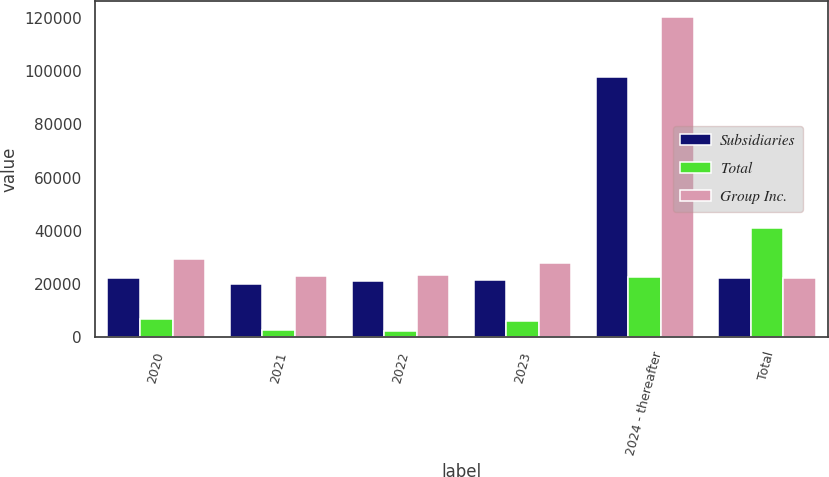<chart> <loc_0><loc_0><loc_500><loc_500><stacked_bar_chart><ecel><fcel>2020<fcel>2021<fcel>2022<fcel>2023<fcel>2024 - thereafter<fcel>Total<nl><fcel>Subsidiaries<fcel>22343<fcel>20128<fcel>21191<fcel>21566<fcel>97878<fcel>22474<nl><fcel>Total<fcel>7028<fcel>2836<fcel>2268<fcel>6306<fcel>22605<fcel>41043<nl><fcel>Group Inc.<fcel>29371<fcel>22964<fcel>23459<fcel>27872<fcel>120483<fcel>22474<nl></chart> 